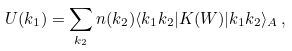<formula> <loc_0><loc_0><loc_500><loc_500>U ( k _ { 1 } ) = \sum _ { k _ { 2 } } n ( k _ { 2 } ) \langle k _ { 1 } k _ { 2 } | K ( W ) | k _ { 1 } k _ { 2 } \rangle _ { A } \, ,</formula> 